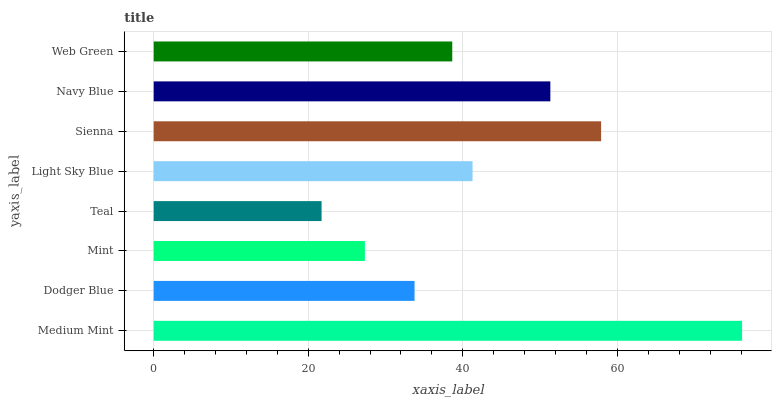Is Teal the minimum?
Answer yes or no. Yes. Is Medium Mint the maximum?
Answer yes or no. Yes. Is Dodger Blue the minimum?
Answer yes or no. No. Is Dodger Blue the maximum?
Answer yes or no. No. Is Medium Mint greater than Dodger Blue?
Answer yes or no. Yes. Is Dodger Blue less than Medium Mint?
Answer yes or no. Yes. Is Dodger Blue greater than Medium Mint?
Answer yes or no. No. Is Medium Mint less than Dodger Blue?
Answer yes or no. No. Is Light Sky Blue the high median?
Answer yes or no. Yes. Is Web Green the low median?
Answer yes or no. Yes. Is Dodger Blue the high median?
Answer yes or no. No. Is Mint the low median?
Answer yes or no. No. 